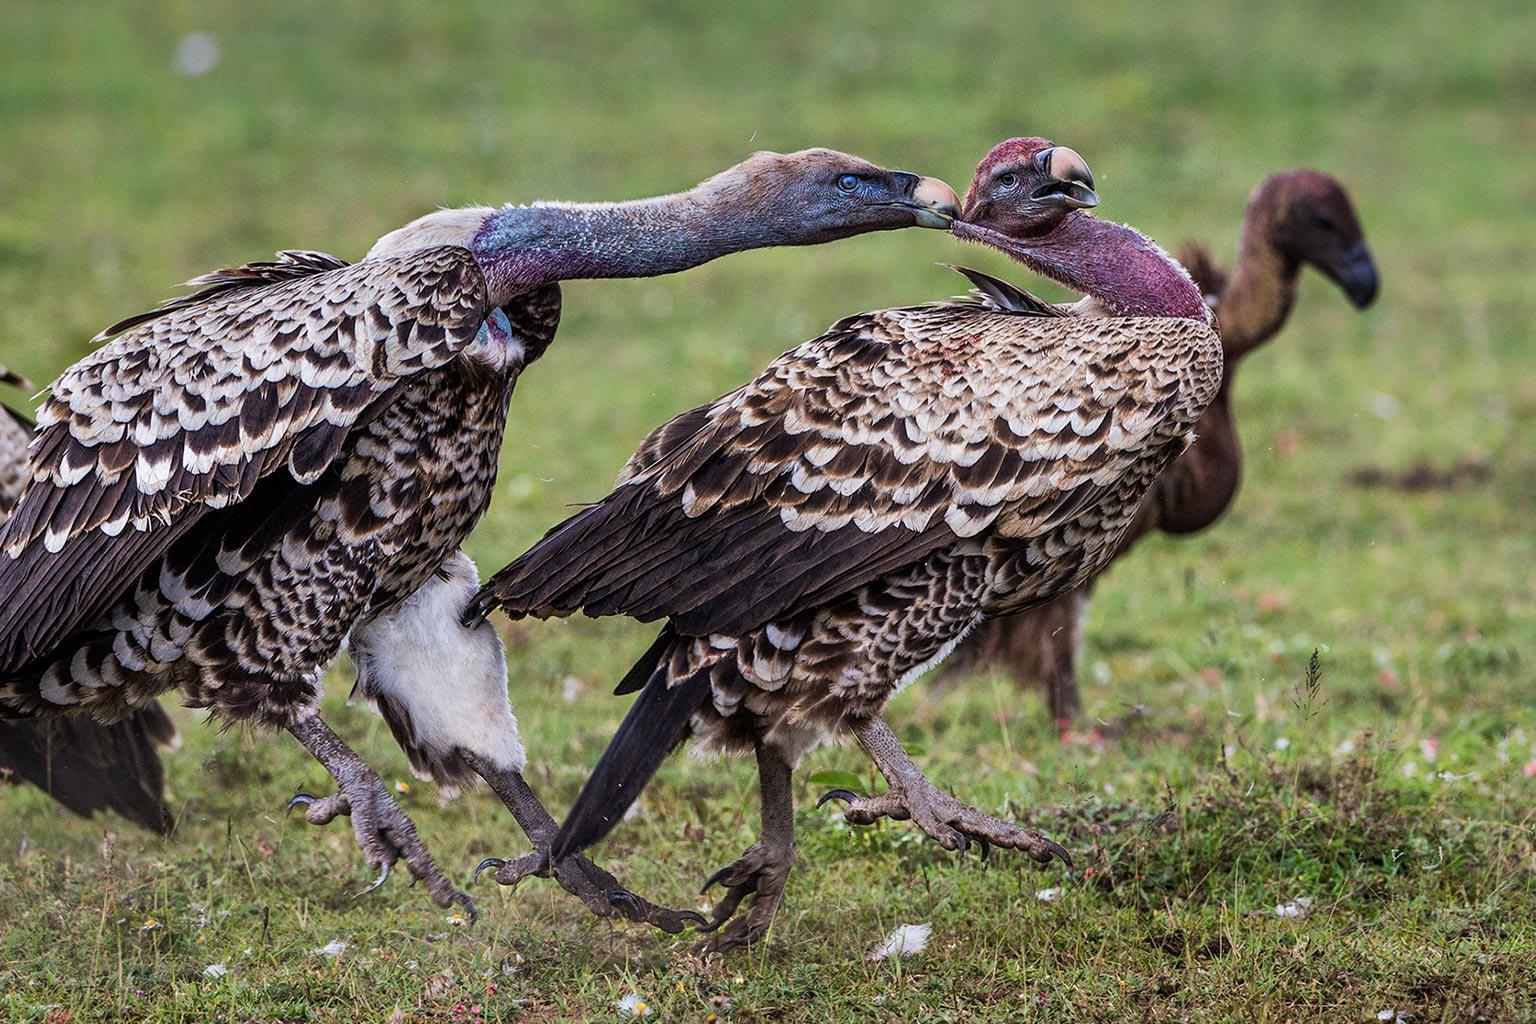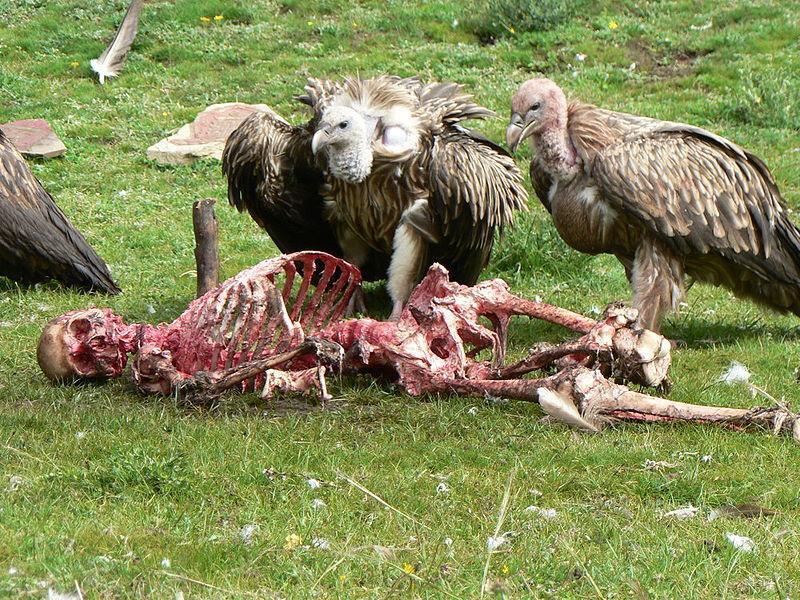The first image is the image on the left, the second image is the image on the right. Analyze the images presented: Is the assertion "There is no more than one bird on the left image." valid? Answer yes or no. No. 